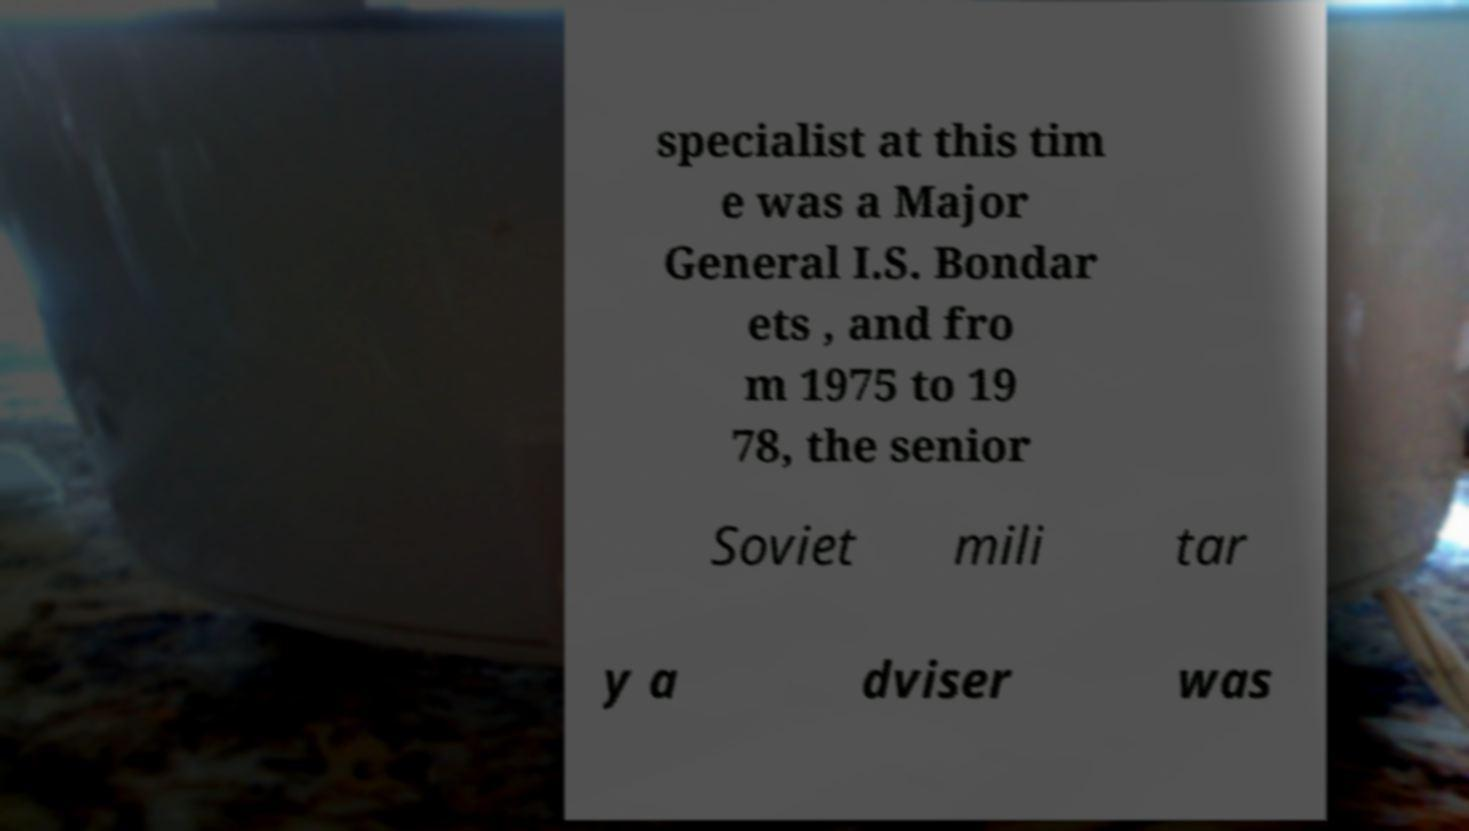Can you accurately transcribe the text from the provided image for me? specialist at this tim e was a Major General I.S. Bondar ets , and fro m 1975 to 19 78, the senior Soviet mili tar y a dviser was 